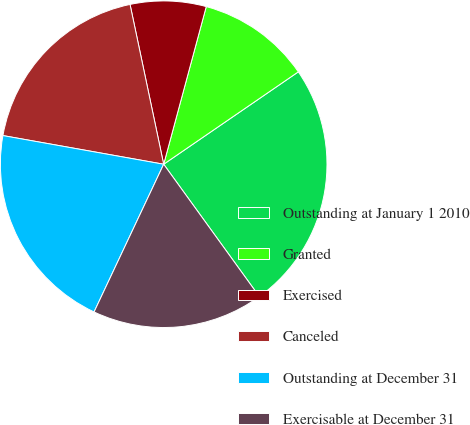Convert chart. <chart><loc_0><loc_0><loc_500><loc_500><pie_chart><fcel>Outstanding at January 1 2010<fcel>Granted<fcel>Exercised<fcel>Canceled<fcel>Outstanding at December 31<fcel>Exercisable at December 31<nl><fcel>24.61%<fcel>11.23%<fcel>7.5%<fcel>18.89%<fcel>20.8%<fcel>16.97%<nl></chart> 